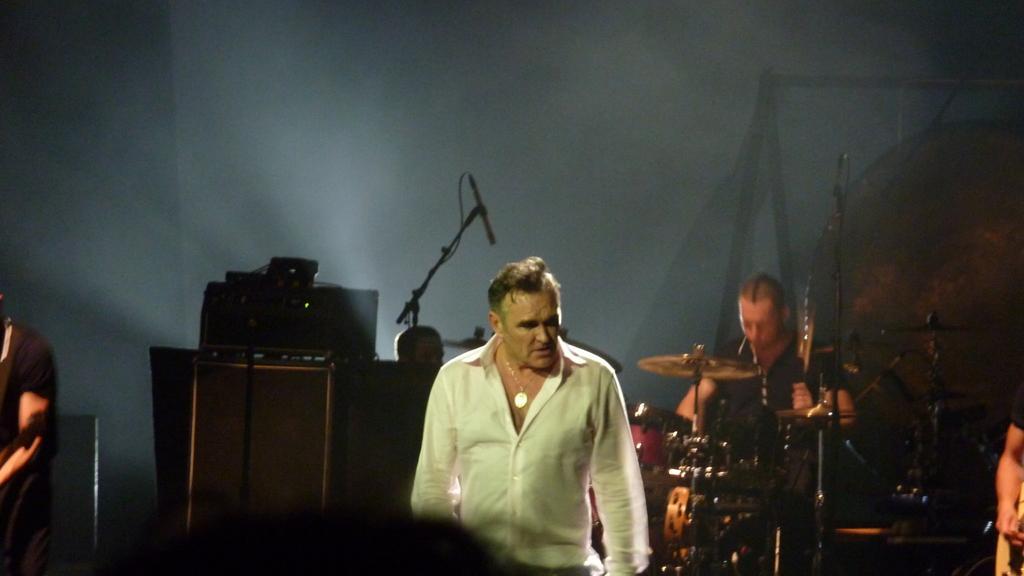Describe this image in one or two sentences. In this picture we can see man sitting and playing drums. This is a mike. We can see a man wearing a white colour shirt, standing. Here we can see devices. At the right side of the picture we can see partial part of a man playing guitar. 